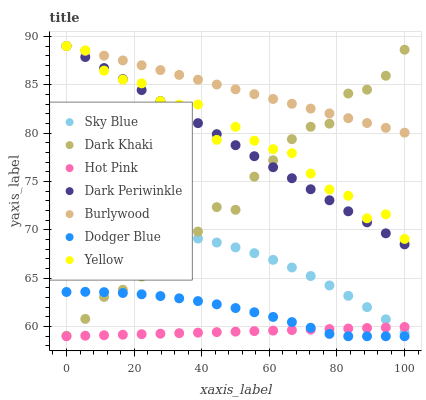Does Hot Pink have the minimum area under the curve?
Answer yes or no. Yes. Does Burlywood have the maximum area under the curve?
Answer yes or no. Yes. Does Yellow have the minimum area under the curve?
Answer yes or no. No. Does Yellow have the maximum area under the curve?
Answer yes or no. No. Is Hot Pink the smoothest?
Answer yes or no. Yes. Is Yellow the roughest?
Answer yes or no. Yes. Is Yellow the smoothest?
Answer yes or no. No. Is Hot Pink the roughest?
Answer yes or no. No. Does Hot Pink have the lowest value?
Answer yes or no. Yes. Does Yellow have the lowest value?
Answer yes or no. No. Does Dark Periwinkle have the highest value?
Answer yes or no. Yes. Does Hot Pink have the highest value?
Answer yes or no. No. Is Dodger Blue less than Burlywood?
Answer yes or no. Yes. Is Sky Blue greater than Dodger Blue?
Answer yes or no. Yes. Does Dark Khaki intersect Dodger Blue?
Answer yes or no. Yes. Is Dark Khaki less than Dodger Blue?
Answer yes or no. No. Is Dark Khaki greater than Dodger Blue?
Answer yes or no. No. Does Dodger Blue intersect Burlywood?
Answer yes or no. No. 